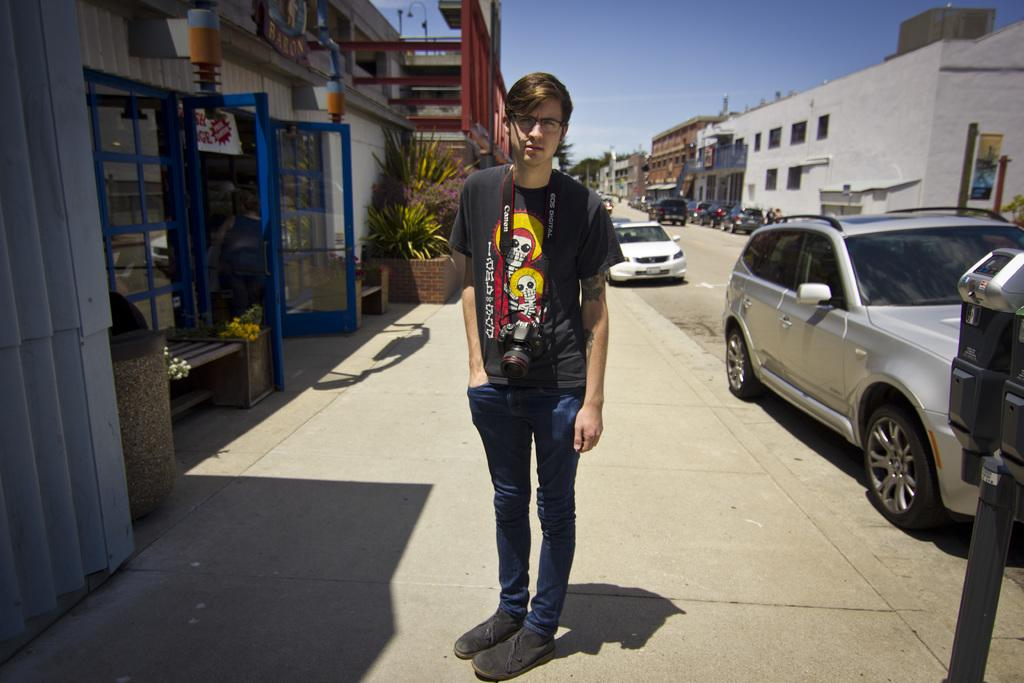What is the man in the image holding? The man in the image is holding a camera. Where is the man standing in the image? The man is standing on a footpath in the image. What is behind the man in the image? The man is in front of a building in the image. Who is the man looking at in the image? The man is looking at someone in the image. What can be seen on the right side of the image? There are vehicles on the right side of the image. Where are the vehicles located in the image? The vehicles are on the road in the image. What color is the gold rabbit sitting on the sofa in the image? There is no gold rabbit or sofa present in the image. 